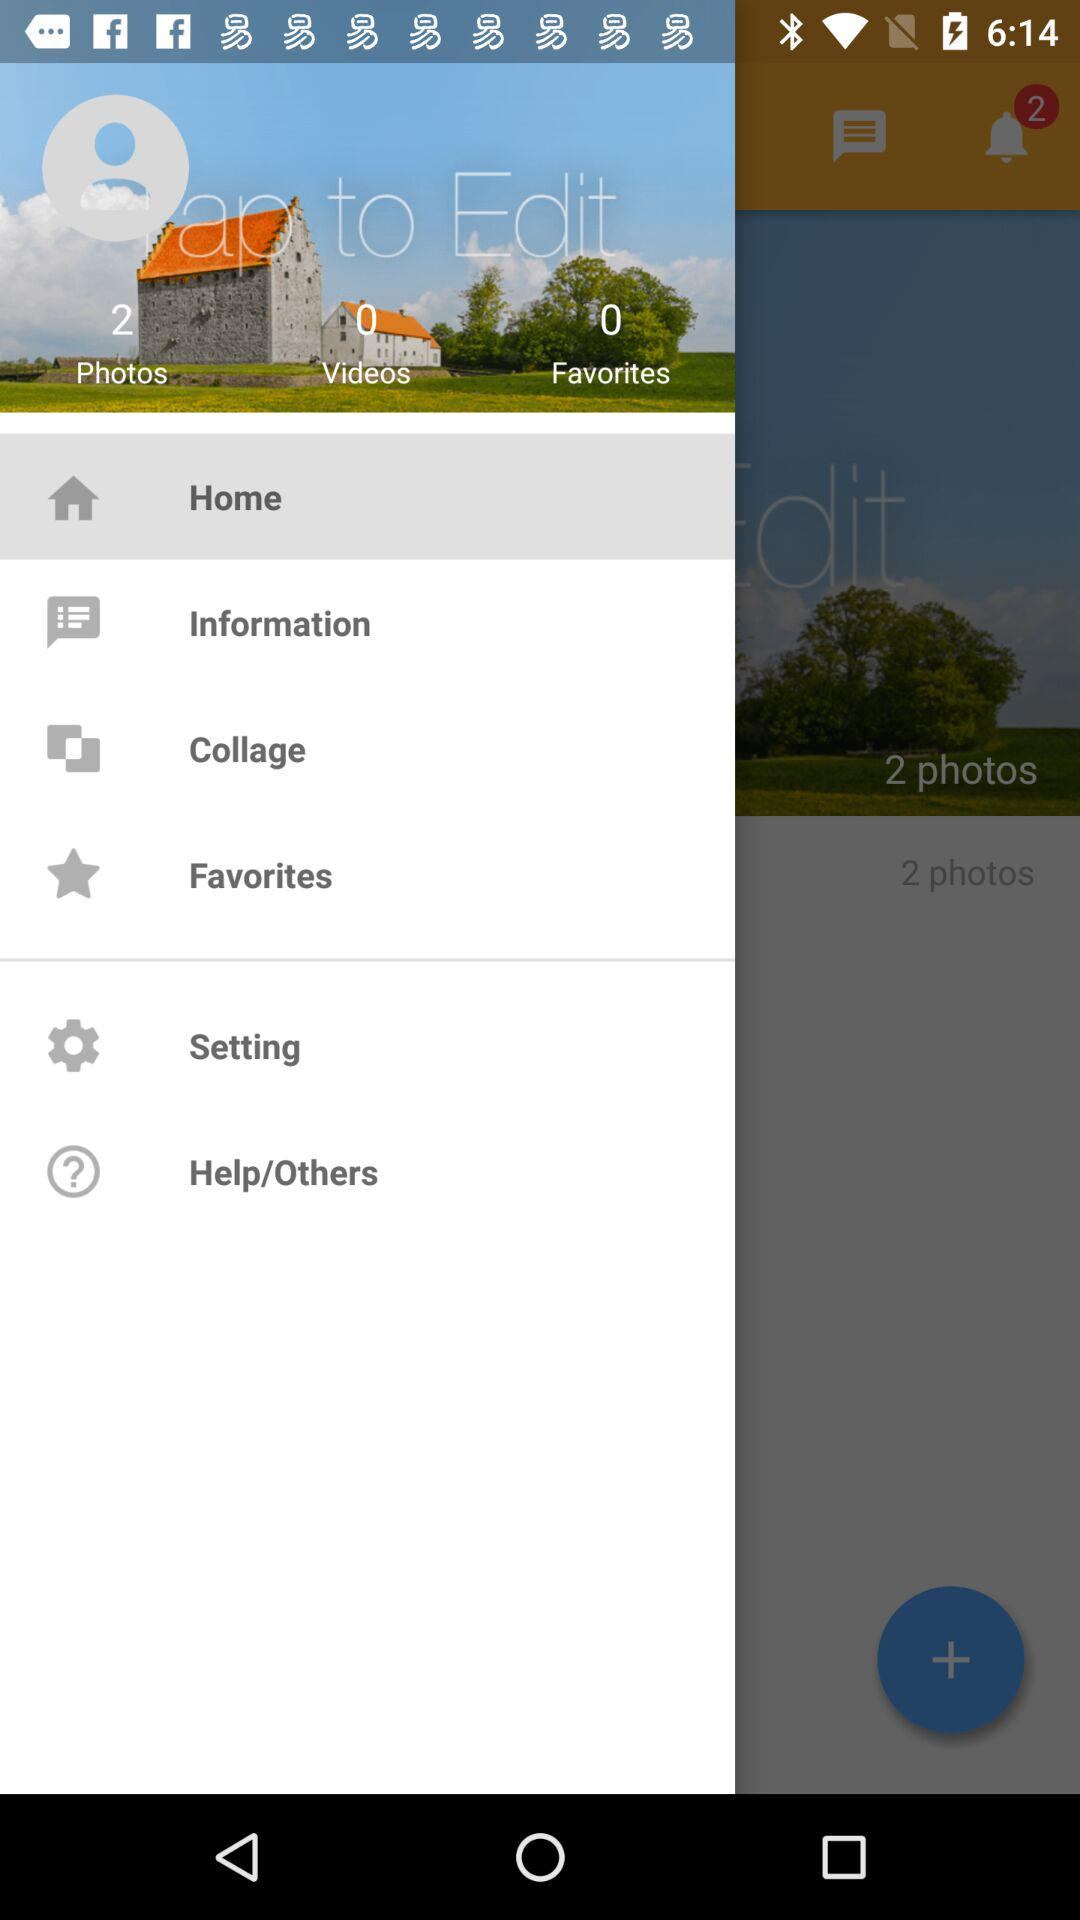How many videos are there? There are 0 videos. 